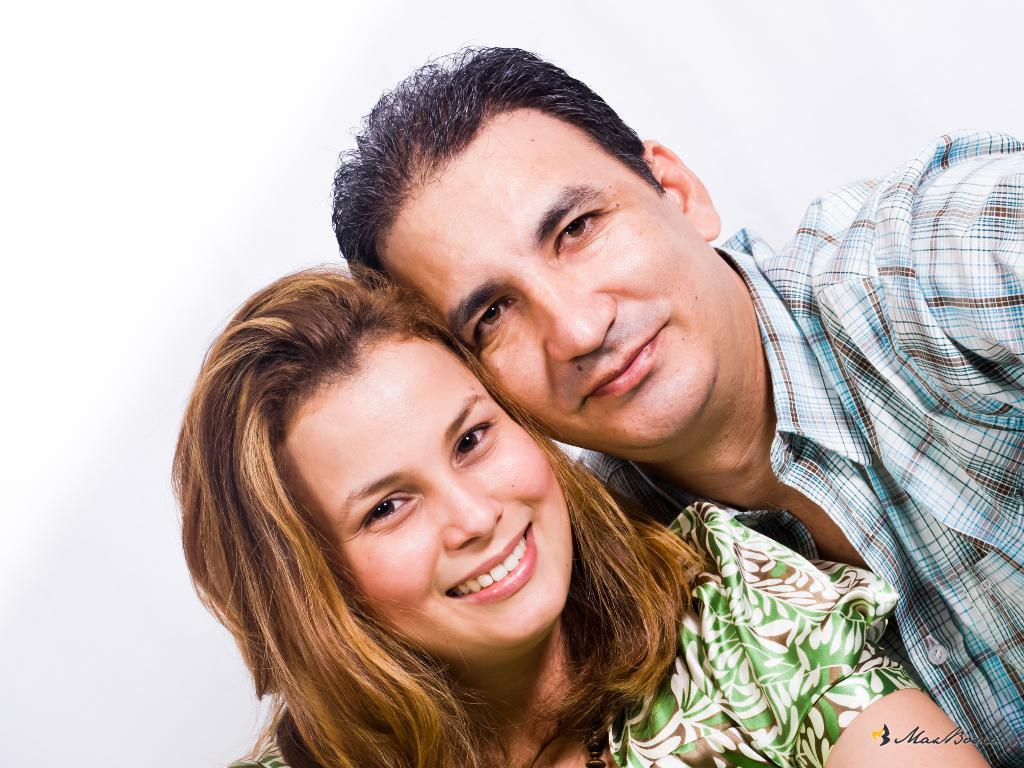How many people are in the image? There are two persons in the image. What are the persons wearing? Both persons are wearing dresses. What type of desk can be seen in the image? There is no desk present in the image. What surprised the persons in the image? The image does not provide any information about a surprise or any emotions of the persons. 